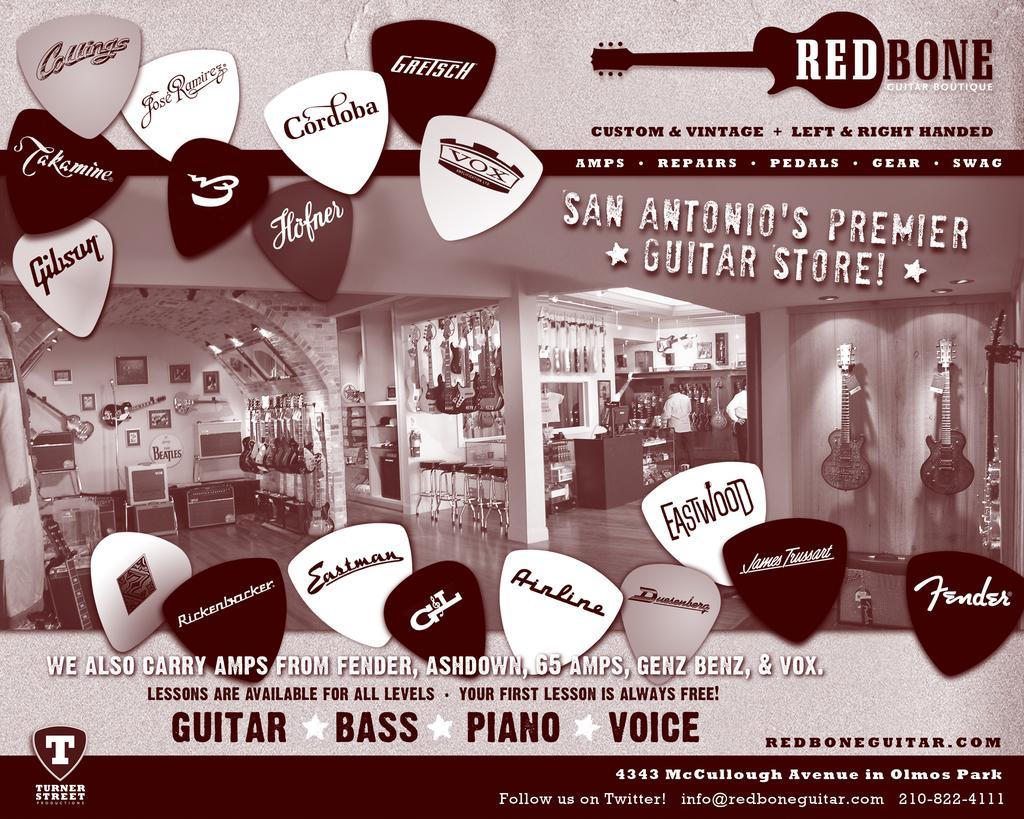Please provide a concise description of this image. in the picture ,there is a poster on the poster we can see a musical instrument shop,in which there are many guitar and musical instruments. 